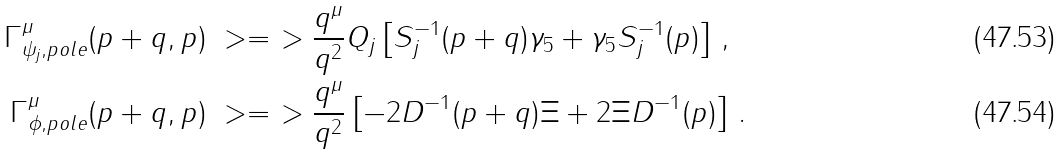<formula> <loc_0><loc_0><loc_500><loc_500>\Gamma ^ { \mu } _ { \psi _ { j } , p o l e } ( p + q , p ) & \ > = \ > \frac { q ^ { \mu } } { q ^ { 2 } } Q _ { j } \left [ S _ { j } ^ { - 1 } ( p + q ) \gamma _ { 5 } + \gamma _ { 5 } S _ { j } ^ { - 1 } ( p ) \right ] \, , \\ \Gamma ^ { \mu } _ { \phi , p o l e } ( p + q , p ) & \ > = \ > \frac { q ^ { \mu } } { q ^ { 2 } } \left [ - 2 D ^ { - 1 } ( p + q ) \Xi + 2 \Xi D ^ { - 1 } ( p ) \right ] \, .</formula> 